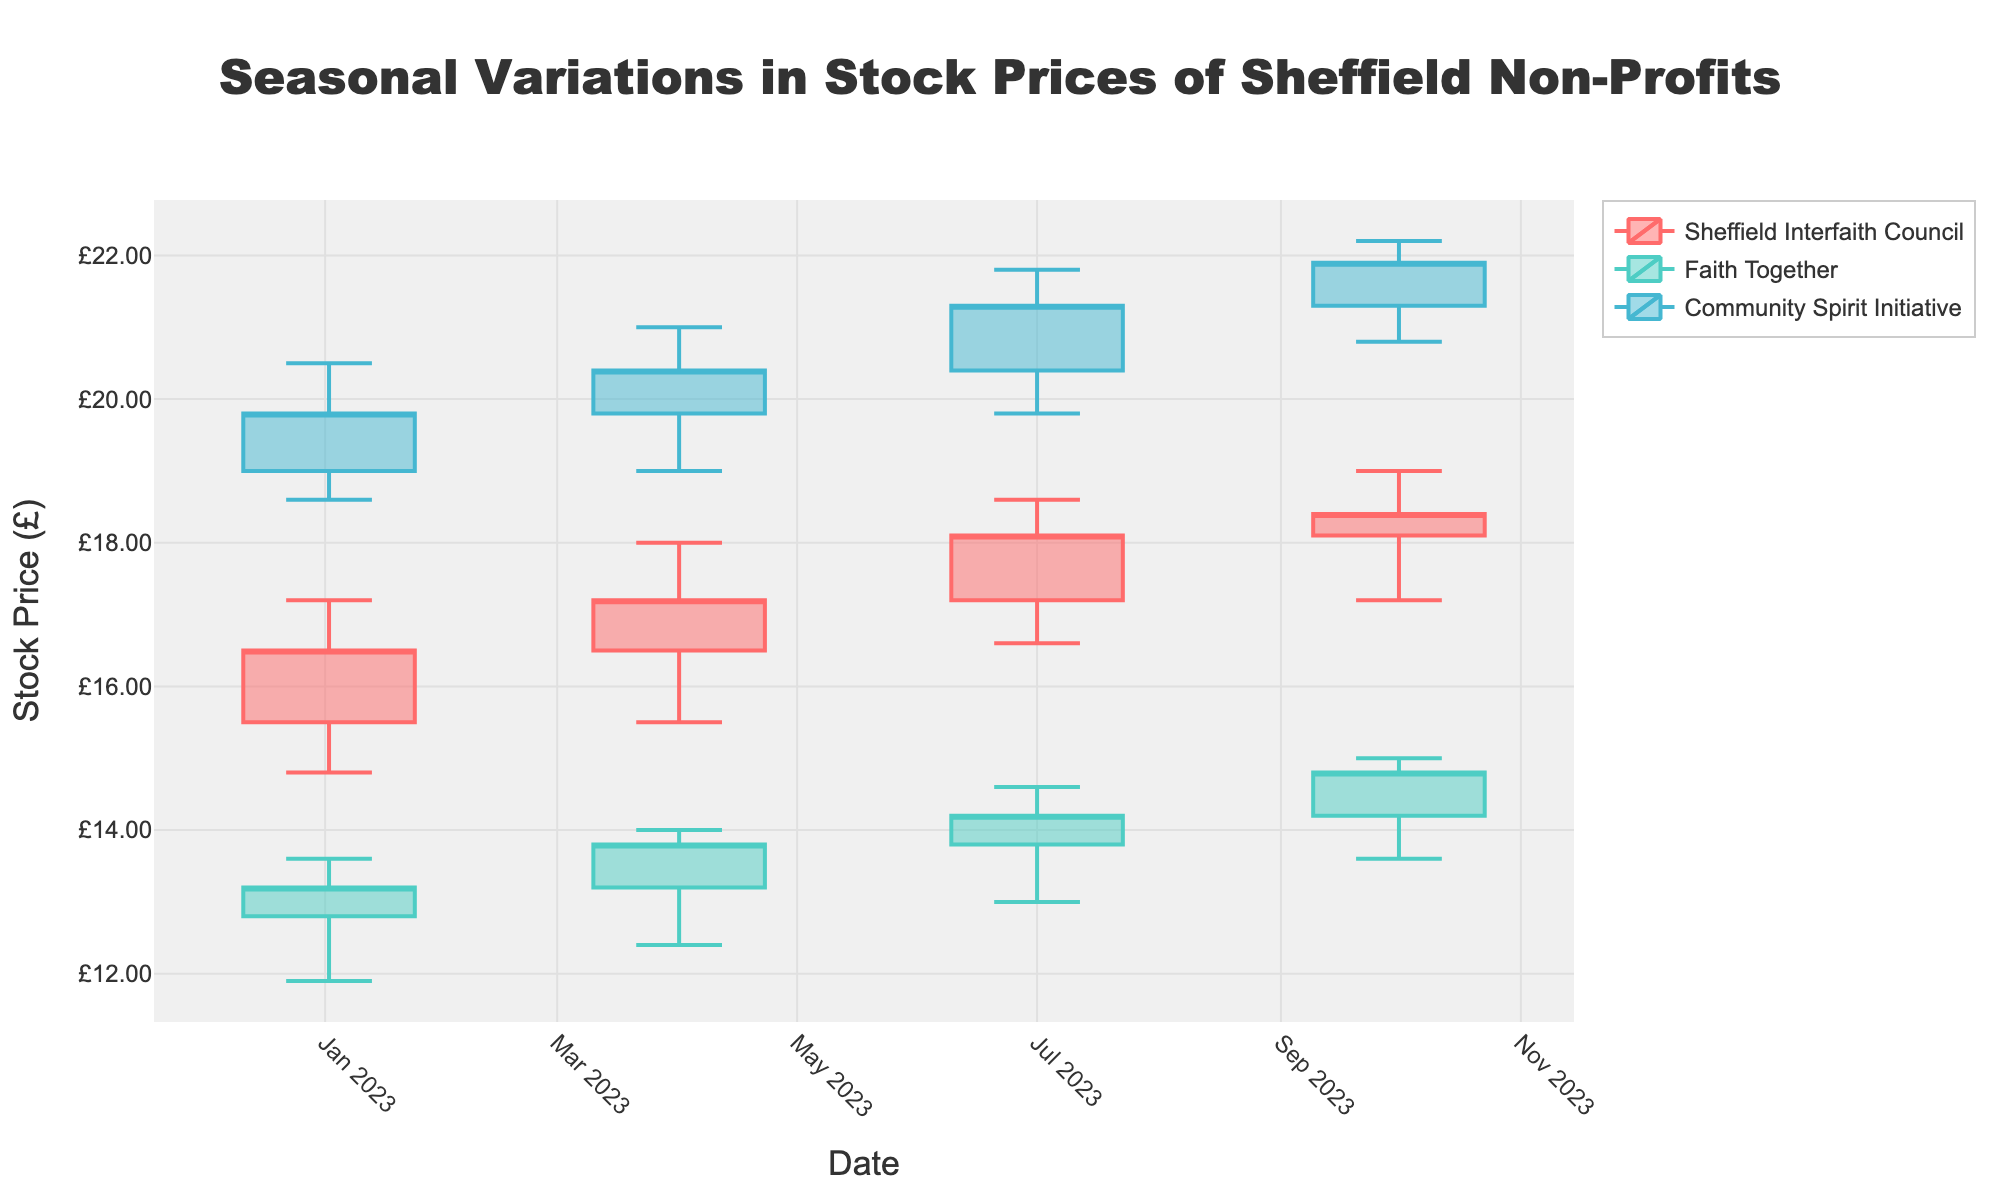What is the title of the figure? The title is typically placed at the top center of the figure. In this case, it states the main context of the chart.
Answer: Seasonal Variations in Stock Prices of Sheffield Non-Profits What is the y-axis labeled as? The y-axis label provides information about what the vertical axis represents.
Answer: Stock Price (£) How many entities are represented in the figure? The number of entities can be determined by checking the unique labels in the legend.
Answer: Three Which entity has the highest stock price in October 2023? Look at the data points for October 2023 and check the high prices for each entity.
Answer: Community Spirit Initiative What is the volume of Sheffield Interfaith Council stock in January 2023? Locate the data point for Sheffield Interfaith Council in January 2023 and check the volume.
Answer: 2550 How did the closing price of 'Faith Together' change from January to April 2023? Compare the closing prices of 'Faith Together' in January and April 2023. Calculate the difference to determine the change.
Answer: Increased by £0.60 What is the average high price of 'Community Spirit Initiative' over the year? Sum the high prices of 'Community Spirit Initiative' for all the time points and divide by the number of time points.
Answer: (20.50 + 21.00 + 21.80 + 22.20)/4 = £21.38 Which entity showed a consistent increase in closing prices from January to October 2023? Check the trend of closing prices for each entity from January to October 2023 to see if they consistently rise.
Answer: Sheffield Interfaith Council What is the difference between the opening and closing price of 'Sheffield Interfaith Council' in July 2023? Find the opening and closing prices for 'Sheffield Interfaith Council' in July 2023 and subtract the opening price from the closing price.
Answer: £0.90 Among the three entities, which had the highest volume of stocks traded across all months? Compare the total volume of trades for each entity by adding up the volumes for all months.
Answer: Community Spirit Initiative 